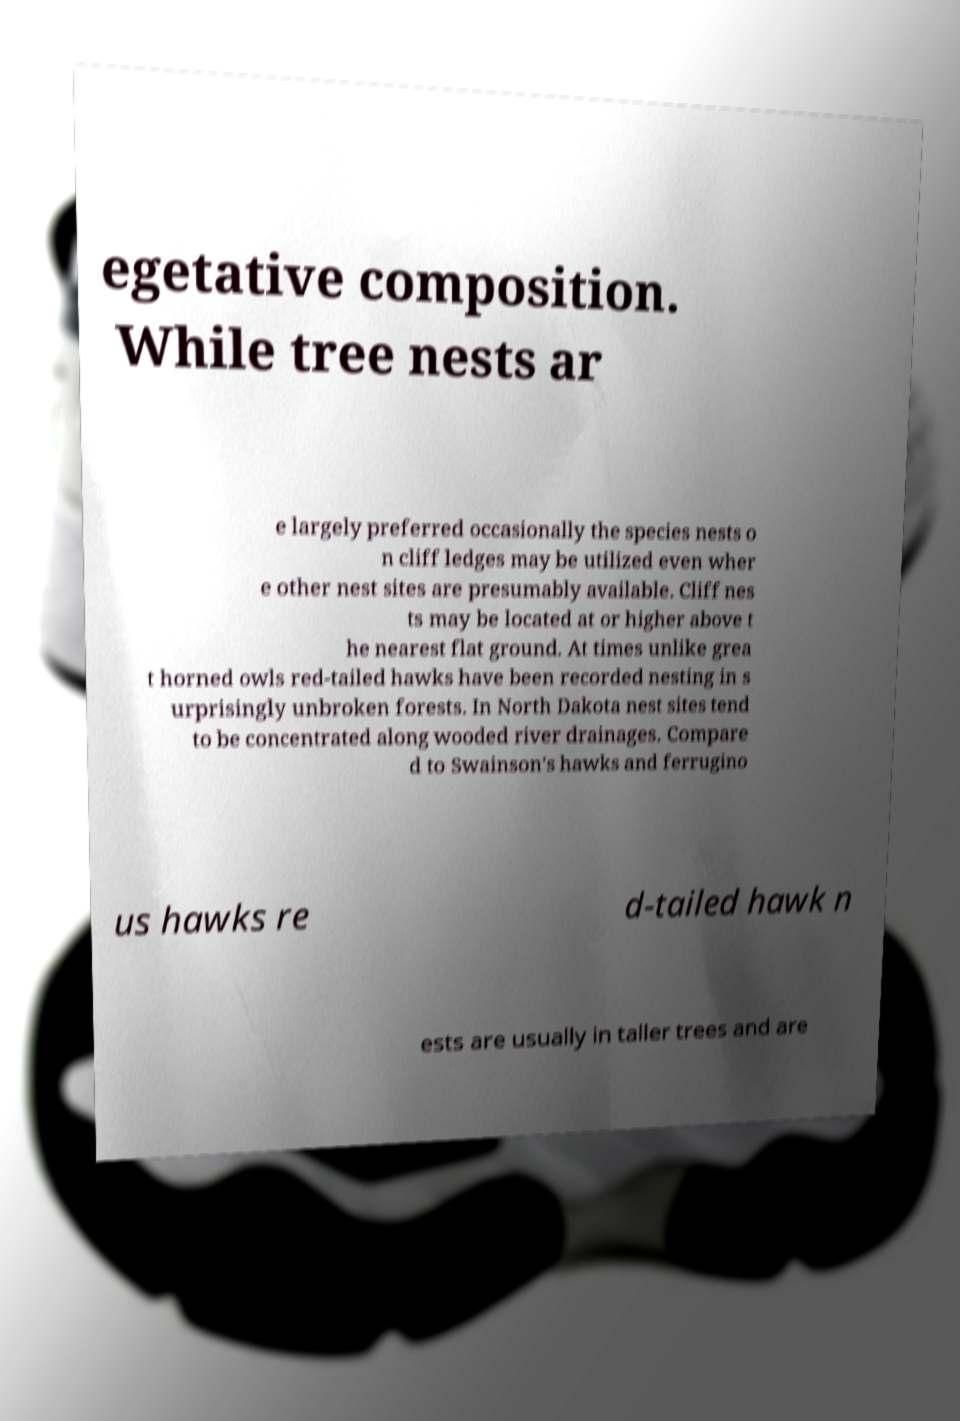Please read and relay the text visible in this image. What does it say? egetative composition. While tree nests ar e largely preferred occasionally the species nests o n cliff ledges may be utilized even wher e other nest sites are presumably available. Cliff nes ts may be located at or higher above t he nearest flat ground. At times unlike grea t horned owls red-tailed hawks have been recorded nesting in s urprisingly unbroken forests. In North Dakota nest sites tend to be concentrated along wooded river drainages. Compare d to Swainson's hawks and ferrugino us hawks re d-tailed hawk n ests are usually in taller trees and are 